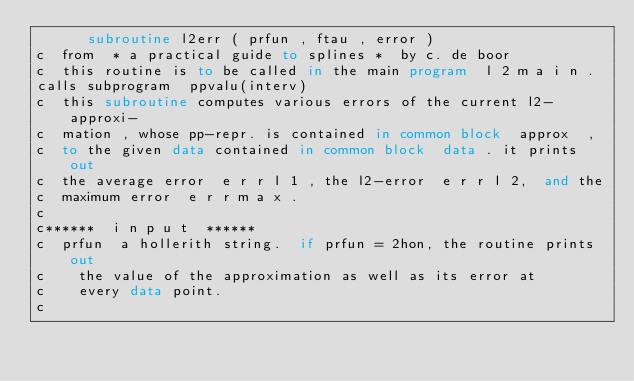<code> <loc_0><loc_0><loc_500><loc_500><_FORTRAN_>      subroutine l2err ( prfun , ftau , error )
c  from  * a practical guide to splines *  by c. de boor
c  this routine is to be called in the main program  l 2 m a i n .
calls subprogram  ppvalu(interv)
c  this subroutine computes various errors of the current l2-approxi-
c  mation , whose pp-repr. is contained in common block  approx  ,
c  to the given data contained in common block	data . it prints out
c  the average error  e r r l 1 , the l2-error	e r r l 2,  and the
c  maximum error  e r r m a x .
c
c******  i n p u t  ******
c  prfun  a hollerith string.  if prfun = 2hon, the routine prints out
c	   the value of the approximation as well as its error at
c	   every data point.
c</code> 